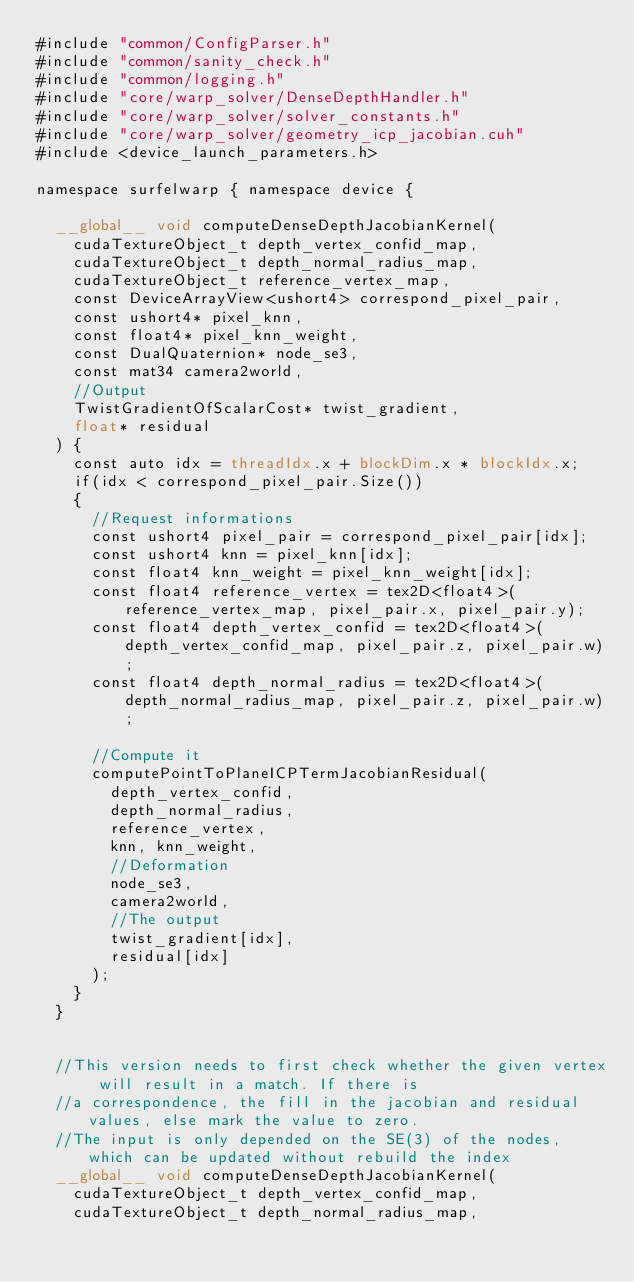Convert code to text. <code><loc_0><loc_0><loc_500><loc_500><_Cuda_>#include "common/ConfigParser.h"
#include "common/sanity_check.h"
#include "common/logging.h"
#include "core/warp_solver/DenseDepthHandler.h"
#include "core/warp_solver/solver_constants.h"
#include "core/warp_solver/geometry_icp_jacobian.cuh"
#include <device_launch_parameters.h>

namespace surfelwarp { namespace device {

	__global__ void computeDenseDepthJacobianKernel(
		cudaTextureObject_t	depth_vertex_confid_map,
		cudaTextureObject_t depth_normal_radius_map,
		cudaTextureObject_t reference_vertex_map,
		const DeviceArrayView<ushort4> correspond_pixel_pair,
		const ushort4* pixel_knn,
		const float4* pixel_knn_weight,
		const DualQuaternion* node_se3,
		const mat34 camera2world,
		//Output
		TwistGradientOfScalarCost* twist_gradient,
		float* residual
	) {
		const auto idx = threadIdx.x + blockDim.x * blockIdx.x;
		if(idx < correspond_pixel_pair.Size())
		{
			//Request informations
			const ushort4 pixel_pair = correspond_pixel_pair[idx];
			const ushort4 knn = pixel_knn[idx];
			const float4 knn_weight = pixel_knn_weight[idx];
			const float4 reference_vertex = tex2D<float4>(reference_vertex_map, pixel_pair.x, pixel_pair.y);
			const float4 depth_vertex_confid = tex2D<float4>(depth_vertex_confid_map, pixel_pair.z, pixel_pair.w);
			const float4 depth_normal_radius = tex2D<float4>(depth_normal_radius_map, pixel_pair.z, pixel_pair.w);

			//Compute it
			computePointToPlaneICPTermJacobianResidual(
				depth_vertex_confid,
				depth_normal_radius, 
				reference_vertex, 
				knn, knn_weight,
				//Deformation
				node_se3, 
				camera2world,
				//The output
				twist_gradient[idx],
				residual[idx]
			);
		}
	}


	//This version needs to first check whether the given vertex will result in a match. If there is
	//a correspondence, the fill in the jacobian and residual values, else mark the value to zero. 
	//The input is only depended on the SE(3) of the nodes, which can be updated without rebuild the index
	__global__ void computeDenseDepthJacobianKernel(
		cudaTextureObject_t depth_vertex_confid_map,
		cudaTextureObject_t depth_normal_radius_map,</code> 